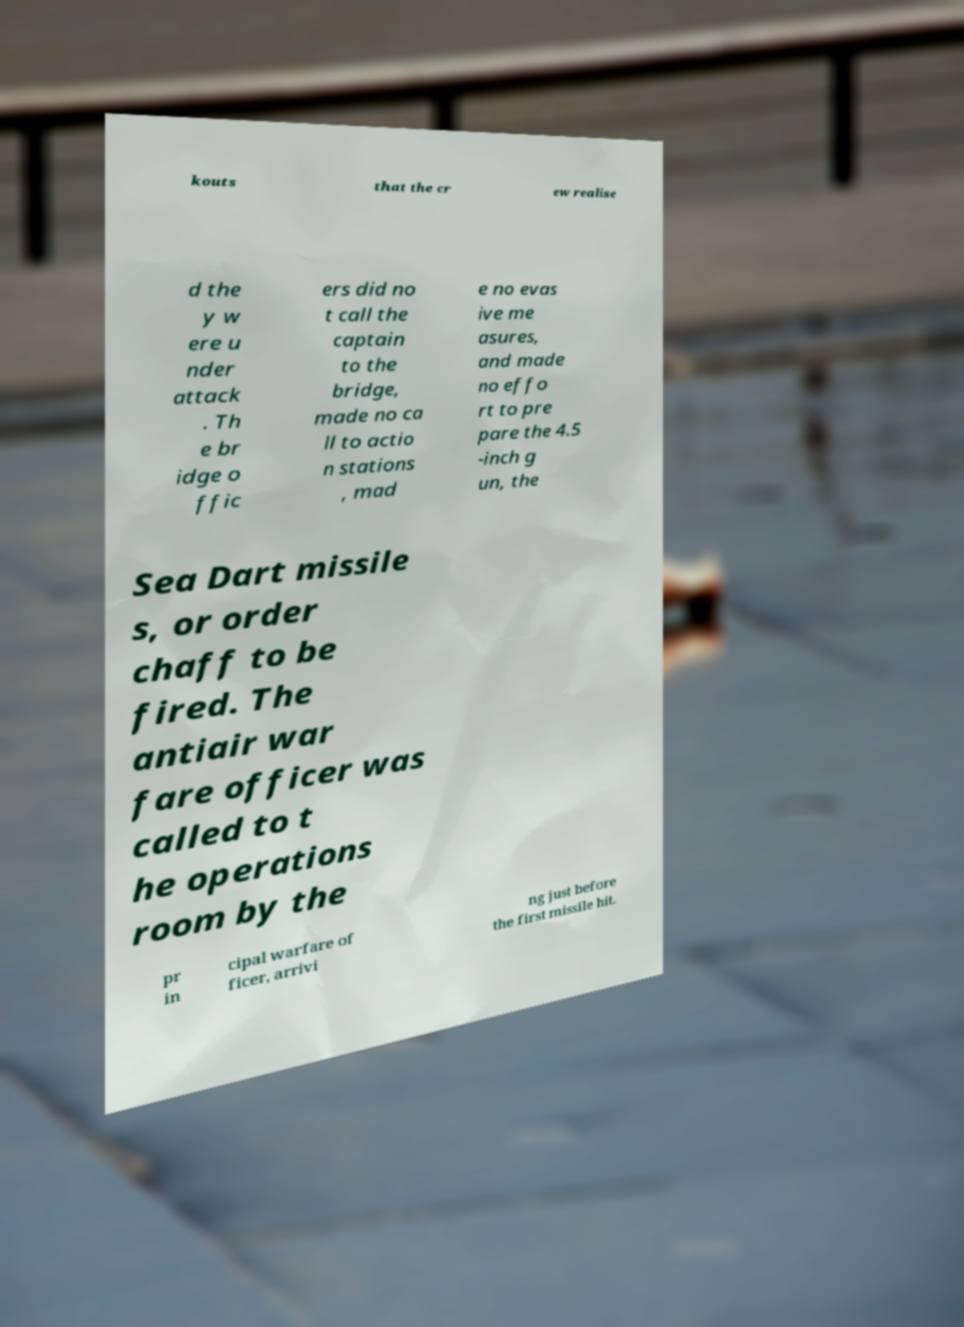Can you read and provide the text displayed in the image?This photo seems to have some interesting text. Can you extract and type it out for me? kouts that the cr ew realise d the y w ere u nder attack . Th e br idge o ffic ers did no t call the captain to the bridge, made no ca ll to actio n stations , mad e no evas ive me asures, and made no effo rt to pre pare the 4.5 -inch g un, the Sea Dart missile s, or order chaff to be fired. The antiair war fare officer was called to t he operations room by the pr in cipal warfare of ficer, arrivi ng just before the first missile hit. 